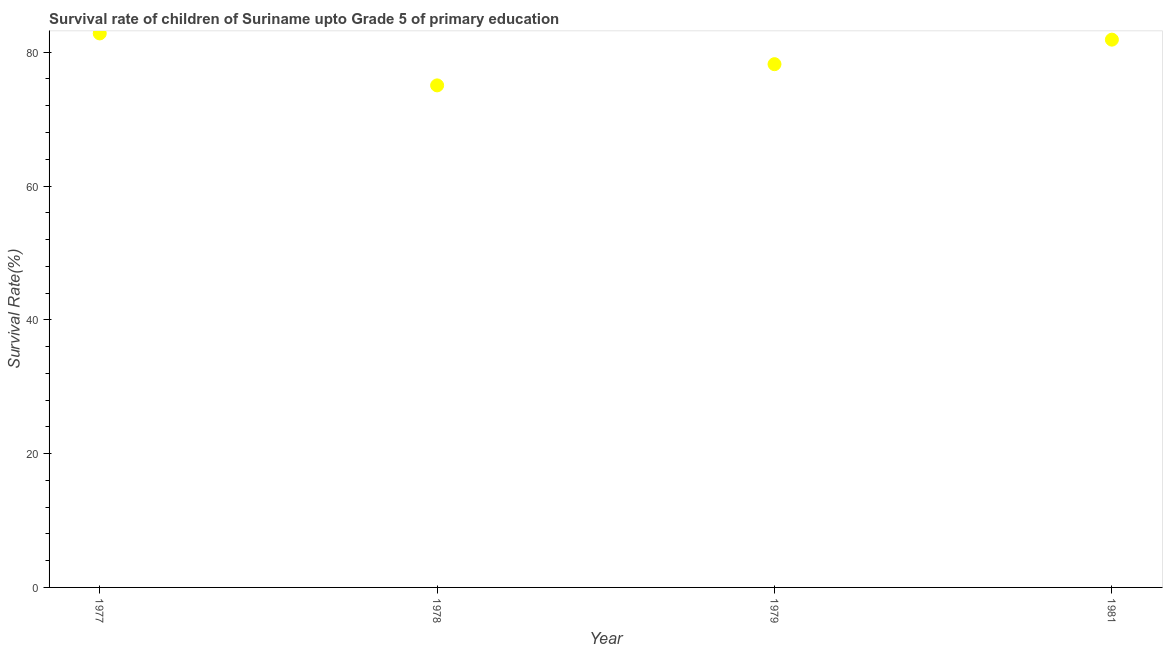What is the survival rate in 1979?
Your response must be concise. 78.22. Across all years, what is the maximum survival rate?
Make the answer very short. 82.81. Across all years, what is the minimum survival rate?
Offer a very short reply. 75.04. In which year was the survival rate maximum?
Your response must be concise. 1977. In which year was the survival rate minimum?
Provide a succinct answer. 1978. What is the sum of the survival rate?
Provide a succinct answer. 317.95. What is the difference between the survival rate in 1979 and 1981?
Your response must be concise. -3.67. What is the average survival rate per year?
Make the answer very short. 79.49. What is the median survival rate?
Make the answer very short. 80.05. In how many years, is the survival rate greater than 4 %?
Offer a terse response. 4. Do a majority of the years between 1979 and 1978 (inclusive) have survival rate greater than 76 %?
Ensure brevity in your answer.  No. What is the ratio of the survival rate in 1977 to that in 1979?
Make the answer very short. 1.06. Is the survival rate in 1977 less than that in 1981?
Your response must be concise. No. What is the difference between the highest and the second highest survival rate?
Provide a succinct answer. 0.93. What is the difference between the highest and the lowest survival rate?
Your answer should be compact. 7.77. In how many years, is the survival rate greater than the average survival rate taken over all years?
Keep it short and to the point. 2. Does the survival rate monotonically increase over the years?
Ensure brevity in your answer.  No. How many dotlines are there?
Keep it short and to the point. 1. How many years are there in the graph?
Offer a very short reply. 4. Are the values on the major ticks of Y-axis written in scientific E-notation?
Make the answer very short. No. Does the graph contain any zero values?
Your answer should be compact. No. Does the graph contain grids?
Offer a terse response. No. What is the title of the graph?
Make the answer very short. Survival rate of children of Suriname upto Grade 5 of primary education. What is the label or title of the X-axis?
Your response must be concise. Year. What is the label or title of the Y-axis?
Provide a succinct answer. Survival Rate(%). What is the Survival Rate(%) in 1977?
Ensure brevity in your answer.  82.81. What is the Survival Rate(%) in 1978?
Ensure brevity in your answer.  75.04. What is the Survival Rate(%) in 1979?
Give a very brief answer. 78.22. What is the Survival Rate(%) in 1981?
Your response must be concise. 81.88. What is the difference between the Survival Rate(%) in 1977 and 1978?
Your response must be concise. 7.77. What is the difference between the Survival Rate(%) in 1977 and 1979?
Your response must be concise. 4.6. What is the difference between the Survival Rate(%) in 1977 and 1981?
Make the answer very short. 0.93. What is the difference between the Survival Rate(%) in 1978 and 1979?
Offer a terse response. -3.17. What is the difference between the Survival Rate(%) in 1978 and 1981?
Offer a terse response. -6.84. What is the difference between the Survival Rate(%) in 1979 and 1981?
Your answer should be compact. -3.67. What is the ratio of the Survival Rate(%) in 1977 to that in 1978?
Your answer should be compact. 1.1. What is the ratio of the Survival Rate(%) in 1977 to that in 1979?
Your answer should be very brief. 1.06. What is the ratio of the Survival Rate(%) in 1977 to that in 1981?
Offer a very short reply. 1.01. What is the ratio of the Survival Rate(%) in 1978 to that in 1981?
Offer a very short reply. 0.92. What is the ratio of the Survival Rate(%) in 1979 to that in 1981?
Your answer should be compact. 0.95. 